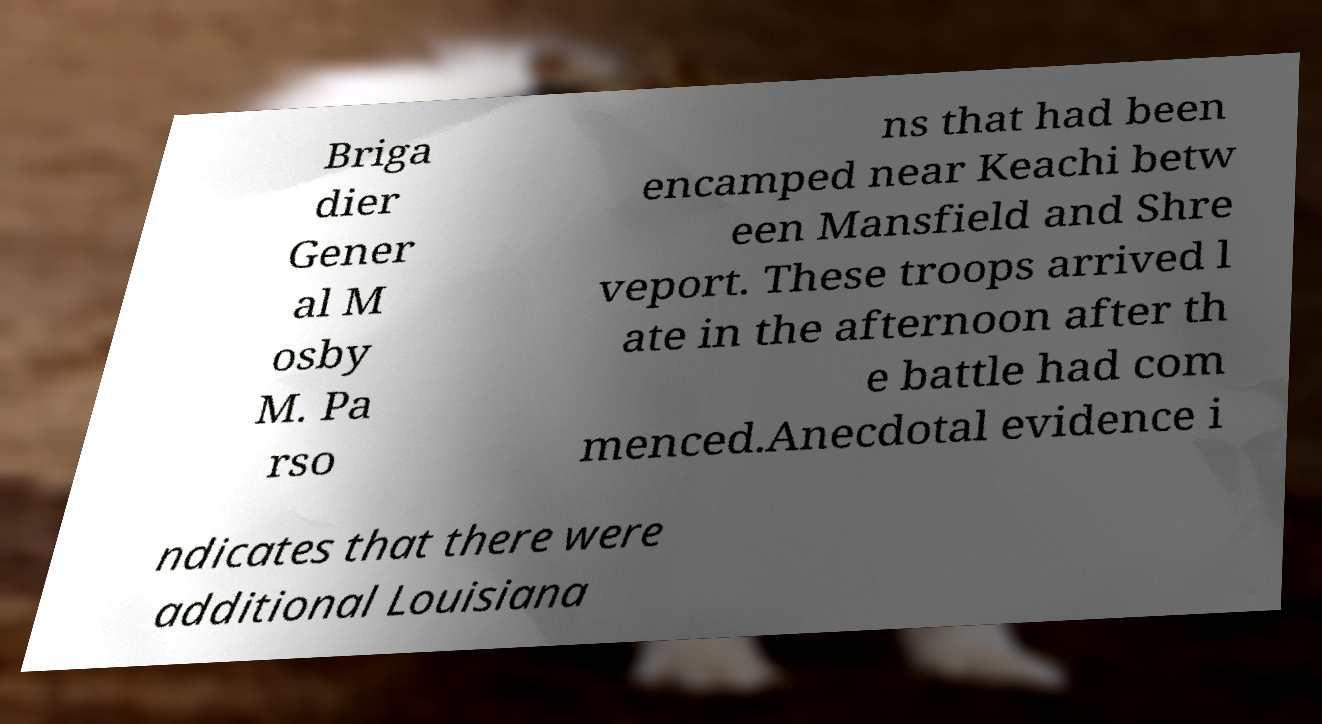For documentation purposes, I need the text within this image transcribed. Could you provide that? Briga dier Gener al M osby M. Pa rso ns that had been encamped near Keachi betw een Mansfield and Shre veport. These troops arrived l ate in the afternoon after th e battle had com menced.Anecdotal evidence i ndicates that there were additional Louisiana 